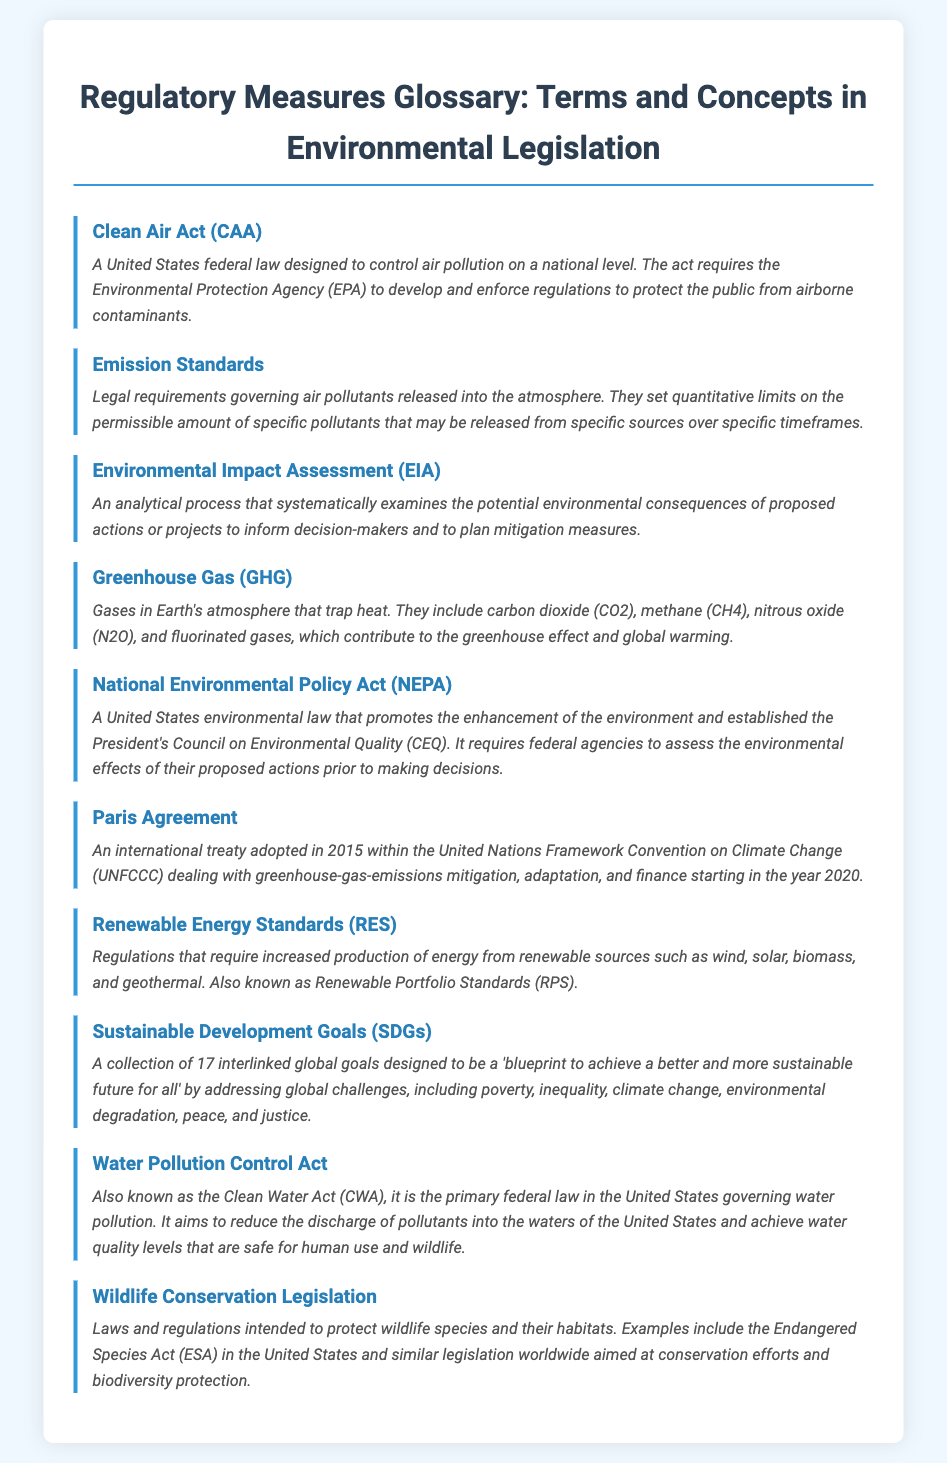what is the Clean Air Act? The Clean Air Act is defined in the document as a United States federal law designed to control air pollution on a national level.
Answer: A United States federal law what does the National Environmental Policy Act require? The National Environmental Policy Act requires federal agencies to assess the environmental effects of their proposed actions prior to making decisions.
Answer: Environmental assessment what year was the Paris Agreement adopted? The document states that the Paris Agreement was adopted in 2015.
Answer: 2015 what are Renewable Energy Standards also known as? The document notes that Renewable Energy Standards are also known as Renewable Portfolio Standards (RPS).
Answer: Renewable Portfolio Standards (RPS) which act aims to reduce water pollution? According to the document, the Water Pollution Control Act is the act that aims to reduce water pollution.
Answer: Water Pollution Control Act what is the focus of the Sustainable Development Goals? The Sustainable Development Goals are focused on achieving a better and more sustainable future for all by addressing global challenges.
Answer: Global challenges what gases are included in Greenhouse Gases? The definition in the document mentions carbon dioxide (CO2), methane (CH4), nitrous oxide (N2O), and fluorinated gases as included in Greenhouse Gases.
Answer: carbon dioxide, methane, nitrous oxide, and fluorinated gases what does the Emission Standards govern? The Emission Standards govern legal requirements for air pollutants released into the atmosphere.
Answer: Air pollutants released what legislation protects wildlife species? The document describes Wildlife Conservation Legislation as laws intended to protect wildlife species.
Answer: Wildlife Conservation Legislation 